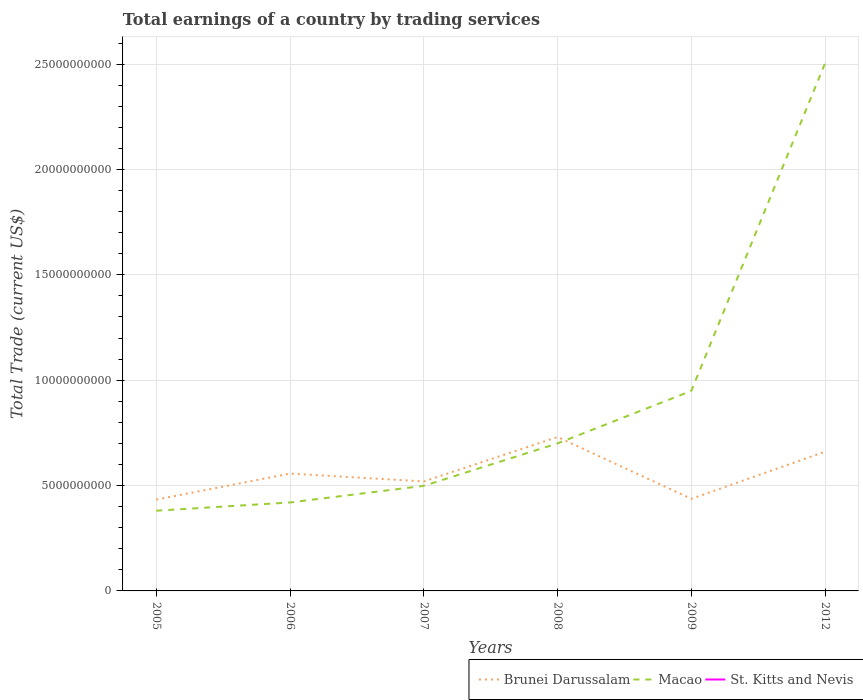How many different coloured lines are there?
Give a very brief answer. 2. Does the line corresponding to Macao intersect with the line corresponding to St. Kitts and Nevis?
Offer a very short reply. No. Across all years, what is the maximum total earnings in Brunei Darussalam?
Your answer should be very brief. 4.34e+09. What is the total total earnings in Macao in the graph?
Give a very brief answer. -4.51e+09. What is the difference between the highest and the second highest total earnings in Macao?
Make the answer very short. 2.12e+1. Is the total earnings in Macao strictly greater than the total earnings in Brunei Darussalam over the years?
Your answer should be compact. No. How many lines are there?
Offer a very short reply. 2. Does the graph contain any zero values?
Provide a short and direct response. Yes. What is the title of the graph?
Ensure brevity in your answer.  Total earnings of a country by trading services. Does "Brazil" appear as one of the legend labels in the graph?
Make the answer very short. No. What is the label or title of the Y-axis?
Provide a short and direct response. Total Trade (current US$). What is the Total Trade (current US$) in Brunei Darussalam in 2005?
Provide a succinct answer. 4.34e+09. What is the Total Trade (current US$) of Macao in 2005?
Your answer should be compact. 3.81e+09. What is the Total Trade (current US$) of Brunei Darussalam in 2006?
Your answer should be compact. 5.57e+09. What is the Total Trade (current US$) in Macao in 2006?
Ensure brevity in your answer.  4.20e+09. What is the Total Trade (current US$) of Brunei Darussalam in 2007?
Your answer should be very brief. 5.20e+09. What is the Total Trade (current US$) of Macao in 2007?
Ensure brevity in your answer.  4.99e+09. What is the Total Trade (current US$) of Brunei Darussalam in 2008?
Your response must be concise. 7.30e+09. What is the Total Trade (current US$) in Macao in 2008?
Offer a terse response. 7.00e+09. What is the Total Trade (current US$) of St. Kitts and Nevis in 2008?
Your answer should be compact. 0. What is the Total Trade (current US$) of Brunei Darussalam in 2009?
Ensure brevity in your answer.  4.37e+09. What is the Total Trade (current US$) in Macao in 2009?
Ensure brevity in your answer.  9.49e+09. What is the Total Trade (current US$) in Brunei Darussalam in 2012?
Your response must be concise. 6.61e+09. What is the Total Trade (current US$) of Macao in 2012?
Ensure brevity in your answer.  2.50e+1. What is the Total Trade (current US$) in St. Kitts and Nevis in 2012?
Make the answer very short. 0. Across all years, what is the maximum Total Trade (current US$) in Brunei Darussalam?
Offer a terse response. 7.30e+09. Across all years, what is the maximum Total Trade (current US$) of Macao?
Give a very brief answer. 2.50e+1. Across all years, what is the minimum Total Trade (current US$) of Brunei Darussalam?
Ensure brevity in your answer.  4.34e+09. Across all years, what is the minimum Total Trade (current US$) in Macao?
Make the answer very short. 3.81e+09. What is the total Total Trade (current US$) of Brunei Darussalam in the graph?
Your answer should be very brief. 3.34e+1. What is the total Total Trade (current US$) in Macao in the graph?
Your response must be concise. 5.45e+1. What is the total Total Trade (current US$) in St. Kitts and Nevis in the graph?
Make the answer very short. 0. What is the difference between the Total Trade (current US$) of Brunei Darussalam in 2005 and that in 2006?
Your answer should be compact. -1.23e+09. What is the difference between the Total Trade (current US$) in Macao in 2005 and that in 2006?
Offer a very short reply. -3.92e+08. What is the difference between the Total Trade (current US$) in Brunei Darussalam in 2005 and that in 2007?
Give a very brief answer. -8.61e+08. What is the difference between the Total Trade (current US$) in Macao in 2005 and that in 2007?
Give a very brief answer. -1.18e+09. What is the difference between the Total Trade (current US$) in Brunei Darussalam in 2005 and that in 2008?
Provide a succinct answer. -2.97e+09. What is the difference between the Total Trade (current US$) of Macao in 2005 and that in 2008?
Your answer should be compact. -3.19e+09. What is the difference between the Total Trade (current US$) of Brunei Darussalam in 2005 and that in 2009?
Ensure brevity in your answer.  -3.50e+07. What is the difference between the Total Trade (current US$) in Macao in 2005 and that in 2009?
Your response must be concise. -5.69e+09. What is the difference between the Total Trade (current US$) in Brunei Darussalam in 2005 and that in 2012?
Ensure brevity in your answer.  -2.27e+09. What is the difference between the Total Trade (current US$) of Macao in 2005 and that in 2012?
Your answer should be compact. -2.12e+1. What is the difference between the Total Trade (current US$) in Brunei Darussalam in 2006 and that in 2007?
Provide a short and direct response. 3.73e+08. What is the difference between the Total Trade (current US$) in Macao in 2006 and that in 2007?
Your answer should be compact. -7.88e+08. What is the difference between the Total Trade (current US$) of Brunei Darussalam in 2006 and that in 2008?
Keep it short and to the point. -1.74e+09. What is the difference between the Total Trade (current US$) in Macao in 2006 and that in 2008?
Your answer should be compact. -2.80e+09. What is the difference between the Total Trade (current US$) of Brunei Darussalam in 2006 and that in 2009?
Offer a terse response. 1.20e+09. What is the difference between the Total Trade (current US$) in Macao in 2006 and that in 2009?
Offer a very short reply. -5.29e+09. What is the difference between the Total Trade (current US$) in Brunei Darussalam in 2006 and that in 2012?
Your answer should be very brief. -1.04e+09. What is the difference between the Total Trade (current US$) in Macao in 2006 and that in 2012?
Ensure brevity in your answer.  -2.08e+1. What is the difference between the Total Trade (current US$) of Brunei Darussalam in 2007 and that in 2008?
Make the answer very short. -2.11e+09. What is the difference between the Total Trade (current US$) in Macao in 2007 and that in 2008?
Offer a terse response. -2.01e+09. What is the difference between the Total Trade (current US$) in Brunei Darussalam in 2007 and that in 2009?
Your response must be concise. 8.26e+08. What is the difference between the Total Trade (current US$) of Macao in 2007 and that in 2009?
Ensure brevity in your answer.  -4.51e+09. What is the difference between the Total Trade (current US$) of Brunei Darussalam in 2007 and that in 2012?
Your response must be concise. -1.41e+09. What is the difference between the Total Trade (current US$) in Macao in 2007 and that in 2012?
Give a very brief answer. -2.01e+1. What is the difference between the Total Trade (current US$) of Brunei Darussalam in 2008 and that in 2009?
Give a very brief answer. 2.93e+09. What is the difference between the Total Trade (current US$) in Macao in 2008 and that in 2009?
Make the answer very short. -2.49e+09. What is the difference between the Total Trade (current US$) in Brunei Darussalam in 2008 and that in 2012?
Provide a succinct answer. 6.96e+08. What is the difference between the Total Trade (current US$) in Macao in 2008 and that in 2012?
Your answer should be very brief. -1.80e+1. What is the difference between the Total Trade (current US$) of Brunei Darussalam in 2009 and that in 2012?
Ensure brevity in your answer.  -2.24e+09. What is the difference between the Total Trade (current US$) in Macao in 2009 and that in 2012?
Offer a terse response. -1.56e+1. What is the difference between the Total Trade (current US$) in Brunei Darussalam in 2005 and the Total Trade (current US$) in Macao in 2006?
Give a very brief answer. 1.37e+08. What is the difference between the Total Trade (current US$) of Brunei Darussalam in 2005 and the Total Trade (current US$) of Macao in 2007?
Provide a short and direct response. -6.52e+08. What is the difference between the Total Trade (current US$) of Brunei Darussalam in 2005 and the Total Trade (current US$) of Macao in 2008?
Your answer should be very brief. -2.67e+09. What is the difference between the Total Trade (current US$) of Brunei Darussalam in 2005 and the Total Trade (current US$) of Macao in 2009?
Provide a short and direct response. -5.16e+09. What is the difference between the Total Trade (current US$) of Brunei Darussalam in 2005 and the Total Trade (current US$) of Macao in 2012?
Provide a short and direct response. -2.07e+1. What is the difference between the Total Trade (current US$) in Brunei Darussalam in 2006 and the Total Trade (current US$) in Macao in 2007?
Your answer should be very brief. 5.83e+08. What is the difference between the Total Trade (current US$) of Brunei Darussalam in 2006 and the Total Trade (current US$) of Macao in 2008?
Provide a succinct answer. -1.43e+09. What is the difference between the Total Trade (current US$) in Brunei Darussalam in 2006 and the Total Trade (current US$) in Macao in 2009?
Make the answer very short. -3.92e+09. What is the difference between the Total Trade (current US$) in Brunei Darussalam in 2006 and the Total Trade (current US$) in Macao in 2012?
Provide a succinct answer. -1.95e+1. What is the difference between the Total Trade (current US$) in Brunei Darussalam in 2007 and the Total Trade (current US$) in Macao in 2008?
Make the answer very short. -1.80e+09. What is the difference between the Total Trade (current US$) of Brunei Darussalam in 2007 and the Total Trade (current US$) of Macao in 2009?
Ensure brevity in your answer.  -4.30e+09. What is the difference between the Total Trade (current US$) in Brunei Darussalam in 2007 and the Total Trade (current US$) in Macao in 2012?
Offer a very short reply. -1.98e+1. What is the difference between the Total Trade (current US$) in Brunei Darussalam in 2008 and the Total Trade (current US$) in Macao in 2009?
Keep it short and to the point. -2.19e+09. What is the difference between the Total Trade (current US$) of Brunei Darussalam in 2008 and the Total Trade (current US$) of Macao in 2012?
Keep it short and to the point. -1.77e+1. What is the difference between the Total Trade (current US$) of Brunei Darussalam in 2009 and the Total Trade (current US$) of Macao in 2012?
Provide a short and direct response. -2.07e+1. What is the average Total Trade (current US$) of Brunei Darussalam per year?
Keep it short and to the point. 5.56e+09. What is the average Total Trade (current US$) of Macao per year?
Provide a short and direct response. 9.09e+09. What is the average Total Trade (current US$) in St. Kitts and Nevis per year?
Offer a terse response. 0. In the year 2005, what is the difference between the Total Trade (current US$) of Brunei Darussalam and Total Trade (current US$) of Macao?
Ensure brevity in your answer.  5.29e+08. In the year 2006, what is the difference between the Total Trade (current US$) of Brunei Darussalam and Total Trade (current US$) of Macao?
Make the answer very short. 1.37e+09. In the year 2007, what is the difference between the Total Trade (current US$) in Brunei Darussalam and Total Trade (current US$) in Macao?
Offer a terse response. 2.10e+08. In the year 2008, what is the difference between the Total Trade (current US$) in Brunei Darussalam and Total Trade (current US$) in Macao?
Offer a very short reply. 3.04e+08. In the year 2009, what is the difference between the Total Trade (current US$) in Brunei Darussalam and Total Trade (current US$) in Macao?
Your response must be concise. -5.12e+09. In the year 2012, what is the difference between the Total Trade (current US$) in Brunei Darussalam and Total Trade (current US$) in Macao?
Provide a succinct answer. -1.84e+1. What is the ratio of the Total Trade (current US$) in Brunei Darussalam in 2005 to that in 2006?
Ensure brevity in your answer.  0.78. What is the ratio of the Total Trade (current US$) of Macao in 2005 to that in 2006?
Your answer should be compact. 0.91. What is the ratio of the Total Trade (current US$) of Brunei Darussalam in 2005 to that in 2007?
Keep it short and to the point. 0.83. What is the ratio of the Total Trade (current US$) of Macao in 2005 to that in 2007?
Make the answer very short. 0.76. What is the ratio of the Total Trade (current US$) of Brunei Darussalam in 2005 to that in 2008?
Ensure brevity in your answer.  0.59. What is the ratio of the Total Trade (current US$) of Macao in 2005 to that in 2008?
Make the answer very short. 0.54. What is the ratio of the Total Trade (current US$) in Brunei Darussalam in 2005 to that in 2009?
Give a very brief answer. 0.99. What is the ratio of the Total Trade (current US$) in Macao in 2005 to that in 2009?
Give a very brief answer. 0.4. What is the ratio of the Total Trade (current US$) in Brunei Darussalam in 2005 to that in 2012?
Offer a terse response. 0.66. What is the ratio of the Total Trade (current US$) in Macao in 2005 to that in 2012?
Your response must be concise. 0.15. What is the ratio of the Total Trade (current US$) of Brunei Darussalam in 2006 to that in 2007?
Give a very brief answer. 1.07. What is the ratio of the Total Trade (current US$) of Macao in 2006 to that in 2007?
Your response must be concise. 0.84. What is the ratio of the Total Trade (current US$) of Brunei Darussalam in 2006 to that in 2008?
Provide a short and direct response. 0.76. What is the ratio of the Total Trade (current US$) in Macao in 2006 to that in 2008?
Provide a succinct answer. 0.6. What is the ratio of the Total Trade (current US$) in Brunei Darussalam in 2006 to that in 2009?
Provide a succinct answer. 1.27. What is the ratio of the Total Trade (current US$) of Macao in 2006 to that in 2009?
Offer a terse response. 0.44. What is the ratio of the Total Trade (current US$) of Brunei Darussalam in 2006 to that in 2012?
Your answer should be very brief. 0.84. What is the ratio of the Total Trade (current US$) of Macao in 2006 to that in 2012?
Offer a terse response. 0.17. What is the ratio of the Total Trade (current US$) in Brunei Darussalam in 2007 to that in 2008?
Offer a terse response. 0.71. What is the ratio of the Total Trade (current US$) of Macao in 2007 to that in 2008?
Provide a succinct answer. 0.71. What is the ratio of the Total Trade (current US$) of Brunei Darussalam in 2007 to that in 2009?
Keep it short and to the point. 1.19. What is the ratio of the Total Trade (current US$) of Macao in 2007 to that in 2009?
Your answer should be compact. 0.53. What is the ratio of the Total Trade (current US$) in Brunei Darussalam in 2007 to that in 2012?
Give a very brief answer. 0.79. What is the ratio of the Total Trade (current US$) in Macao in 2007 to that in 2012?
Your response must be concise. 0.2. What is the ratio of the Total Trade (current US$) of Brunei Darussalam in 2008 to that in 2009?
Offer a very short reply. 1.67. What is the ratio of the Total Trade (current US$) of Macao in 2008 to that in 2009?
Make the answer very short. 0.74. What is the ratio of the Total Trade (current US$) of Brunei Darussalam in 2008 to that in 2012?
Offer a very short reply. 1.11. What is the ratio of the Total Trade (current US$) in Macao in 2008 to that in 2012?
Ensure brevity in your answer.  0.28. What is the ratio of the Total Trade (current US$) in Brunei Darussalam in 2009 to that in 2012?
Your answer should be compact. 0.66. What is the ratio of the Total Trade (current US$) in Macao in 2009 to that in 2012?
Offer a very short reply. 0.38. What is the difference between the highest and the second highest Total Trade (current US$) in Brunei Darussalam?
Provide a short and direct response. 6.96e+08. What is the difference between the highest and the second highest Total Trade (current US$) in Macao?
Provide a succinct answer. 1.56e+1. What is the difference between the highest and the lowest Total Trade (current US$) of Brunei Darussalam?
Provide a short and direct response. 2.97e+09. What is the difference between the highest and the lowest Total Trade (current US$) of Macao?
Your response must be concise. 2.12e+1. 